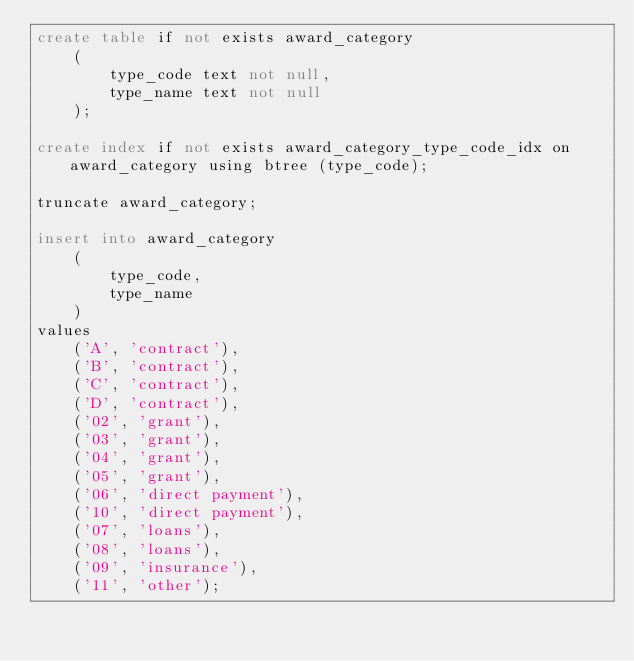Convert code to text. <code><loc_0><loc_0><loc_500><loc_500><_SQL_>create table if not exists award_category
    (
        type_code text not null,
        type_name text not null
    );

create index if not exists award_category_type_code_idx on award_category using btree (type_code);

truncate award_category;

insert into award_category
    (
        type_code,
        type_name
    )
values
    ('A', 'contract'),
    ('B', 'contract'),
    ('C', 'contract'),
    ('D', 'contract'),
    ('02', 'grant'),
    ('03', 'grant'),
    ('04', 'grant'),
    ('05', 'grant'),
    ('06', 'direct payment'),
    ('10', 'direct payment'),
    ('07', 'loans'),
    ('08', 'loans'),
    ('09', 'insurance'),
    ('11', 'other');</code> 